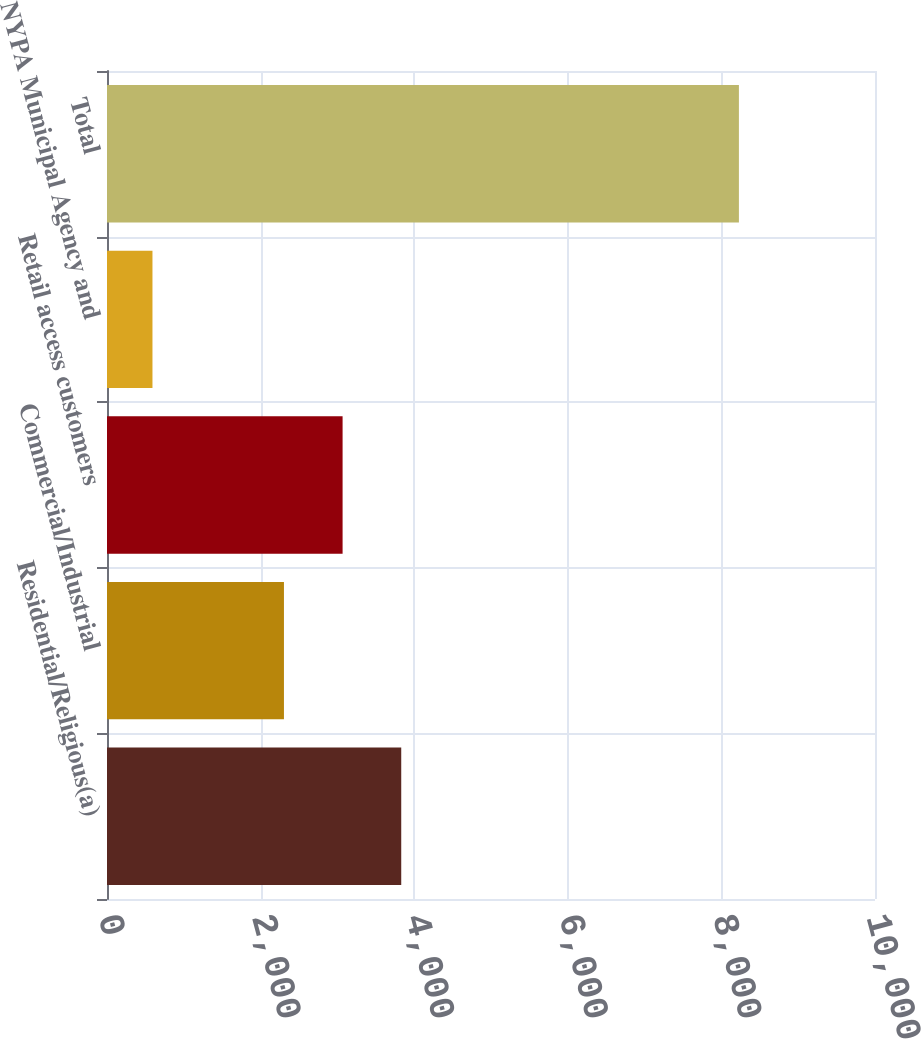<chart> <loc_0><loc_0><loc_500><loc_500><bar_chart><fcel>Residential/Religious(a)<fcel>Commercial/Industrial<fcel>Retail access customers<fcel>NYPA Municipal Agency and<fcel>Total<nl><fcel>3831.2<fcel>2304<fcel>3067.6<fcel>592<fcel>8228<nl></chart> 